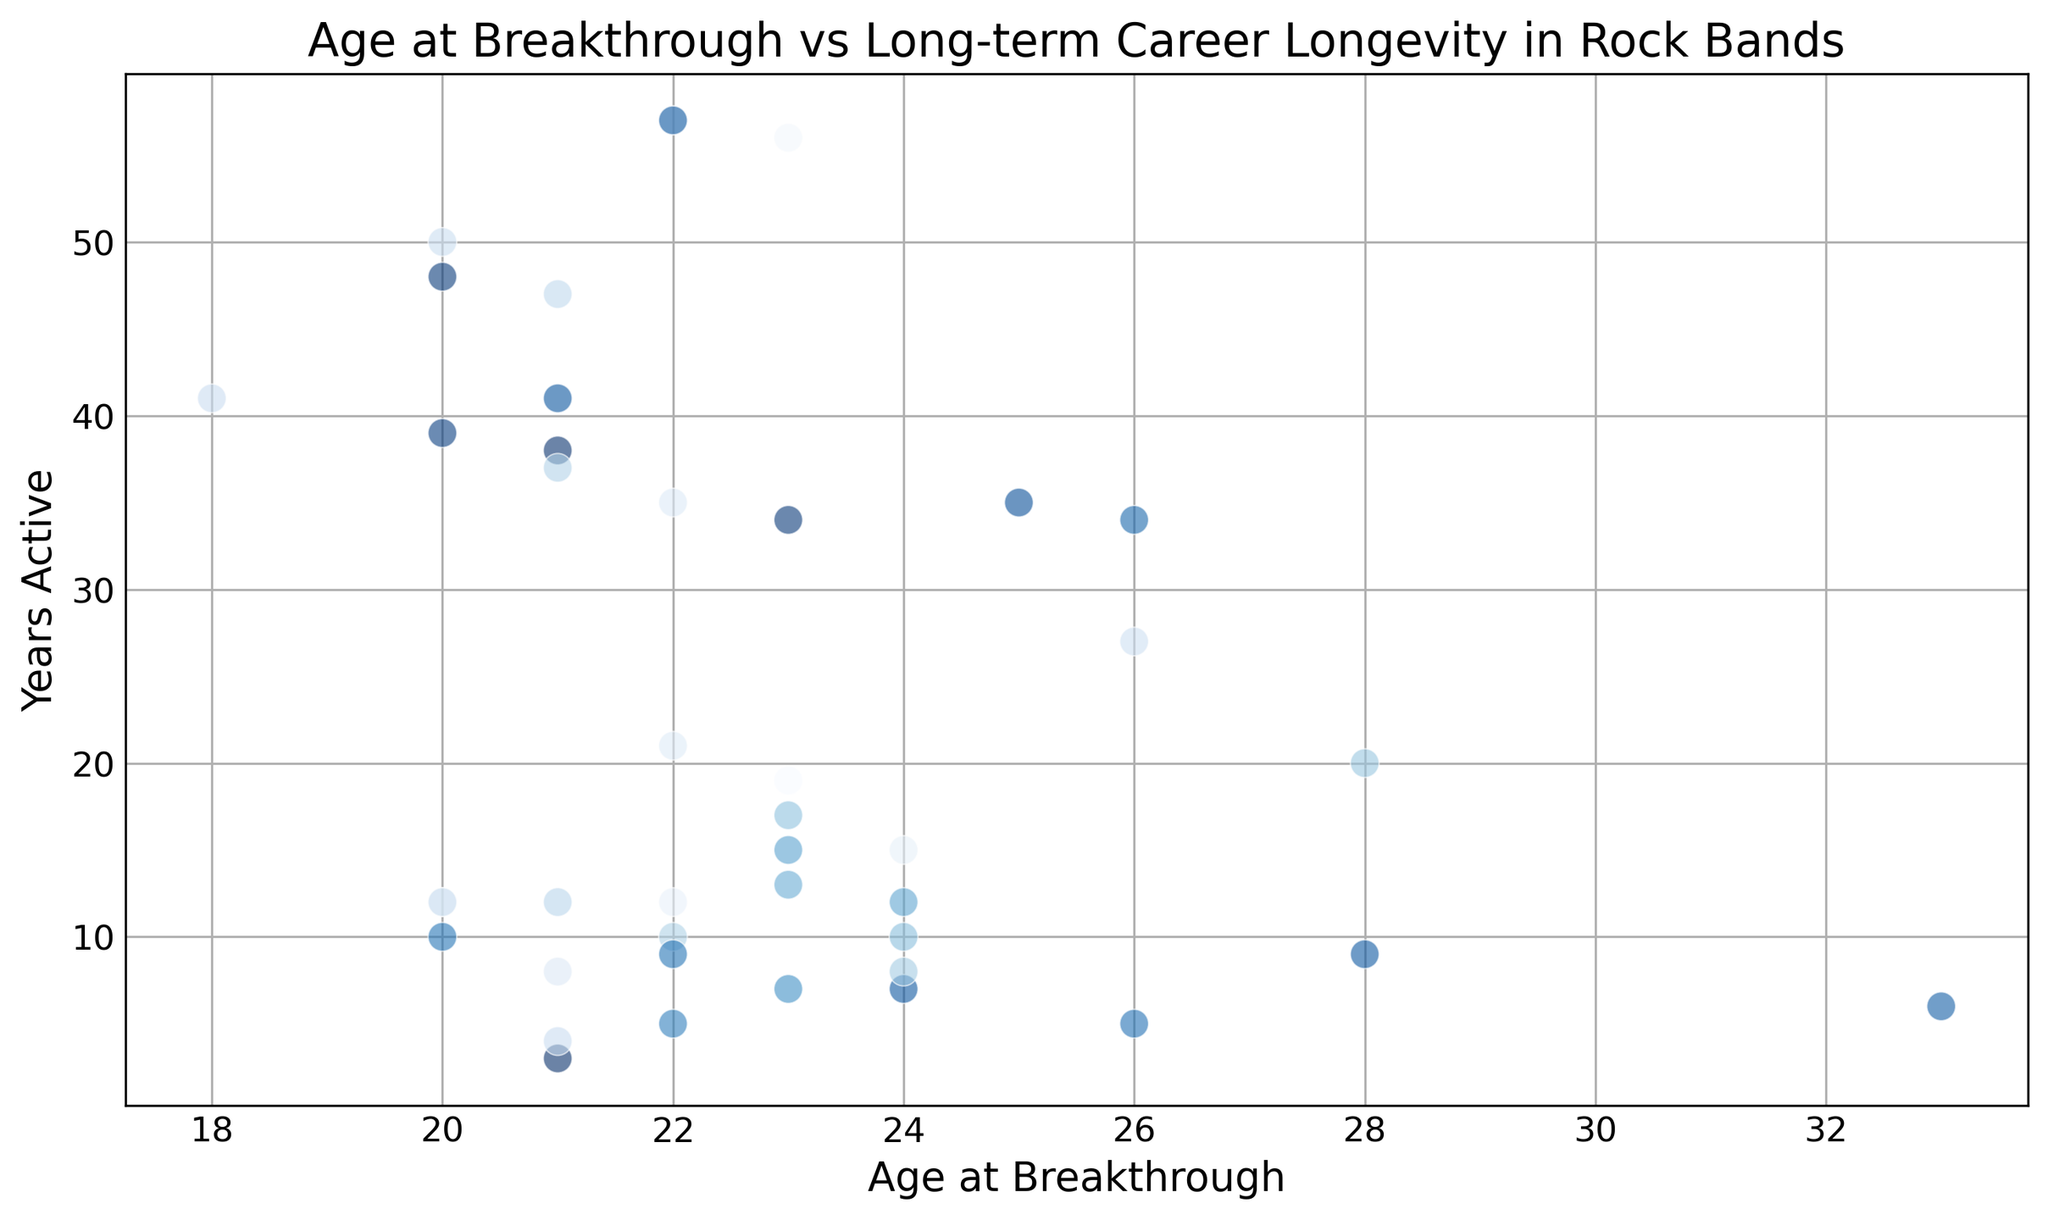Explain the relationship between younger and older breakthrough ages and their career longevity according to the scatter plot To compare the longevity of band members who had their breakthrough at different ages, observe the trend in the data points on the scatter plot. Younger breakthrough ages (around 20-25) show mixed longevity; some members have very long careers (e.g., The Rolling Stones), while others have short careers (e.g., Syd Barrett). In contrast, the few older breakthrough ages (e.g., Freddie Mercury at 28) indicate relatively fewer members, but their careers also have notable longevity.
Answer: Mixed, but notable outliers on both ends Are there more band members who had a breakthrough in their early 20s compared to their late 20s? Look at the concentration of scatter plot points around the early 20s (20-25) and compare it to the points around the late 20s (26-30). There are more points clustered in the 20-25 range than in the 26-30 range.
Answer: Yes Which band member had the longest career, and how old were they at their breakthrough? Identify the point at the highest value on the y-axis (Years Active) and note the corresponding x value (Age at Breakthrough). Mick Jagger and Keith Richards (both 57 years active) of The Rolling Stones had their breakthrough at 22 years old.
Answer: Mick Jagger and Keith Richards, 22 years old Is there a noticeable color pattern across the ages of the breakthrough hits? Examine the spread of colors across the x-axis (Age at Breakthrough). The colors are randomly assigned (based on the code) and do not show any specific pattern correlating with age.
Answer: No, the colors are randomly distributed Who are the members with less than 10 years active and their ages at breakthrough? Look at the points on the scatter plot below the 10 years active mark on the y-axis and identify the corresponding x-axis values for these points. These members include Syd Barrett (21), Jim Morrison (22), and Cliff Burton (21).
Answer: Syd Barrett (21), Jim Morrison (22), Cliff Burton (21) What is the range of breakthrough ages for members with careers longer than 20 years? Observe the y-axis and identify points above the 20 years active mark. Note the corresponding x-axis values for these members. Members such as Mick Jagger (22), Keith Richards (22), Roger Taylor (26), and Lars Ulrich (18) have breakthrough ages spanning from 18 to 26.
Answer: 18 to 26 Do band members who had breakthroughs at 20 years old tend to have longer or shorter careers? Check the career longevity of band members who had their breakthrough at age 20 on the scatter plot. The values for years active for members at age 20 vary, with some having long careers (e.g., Angus Young 48) and others with shorter ones.
Answer: Mixed, with both long and short careers 